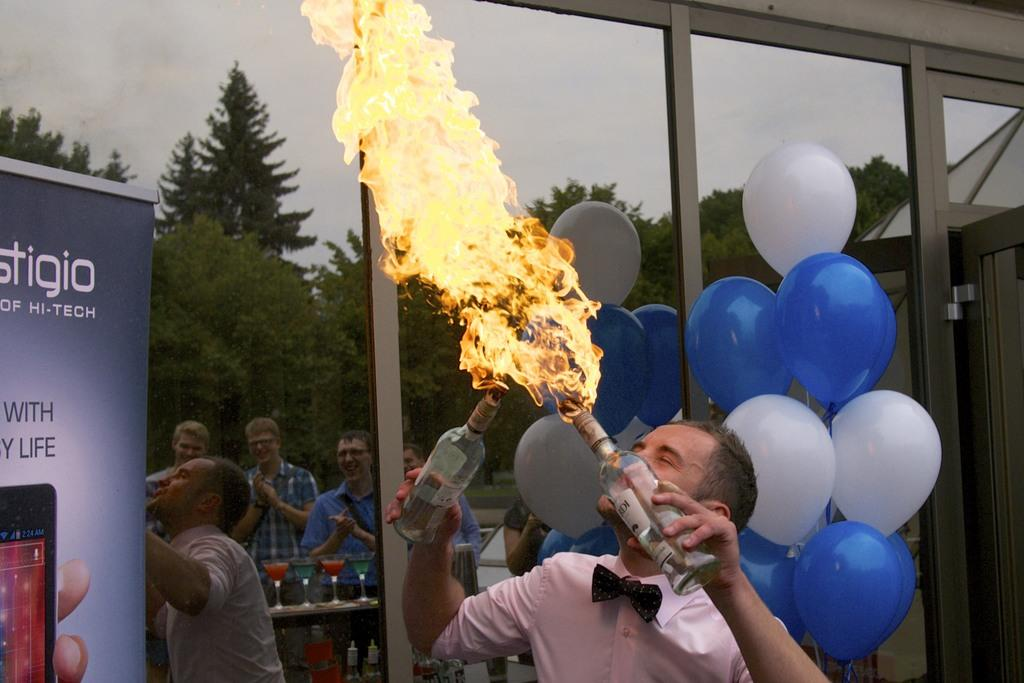What is the main subject of the picture? The main subject of the picture is a man. What is the man doing in the image? The man is holding two bottles with fire and performing. What else can be seen in the image besides the man? There are balloons, a glass door, and people standing in the image. What type of development can be seen taking place near the border in the image? There is no development or border present in the image; it features a man performing with fire bottles. Can you describe the bun the man is wearing in the image? There is no bun visible on the man in the image; he is holding two bottles with fire. 